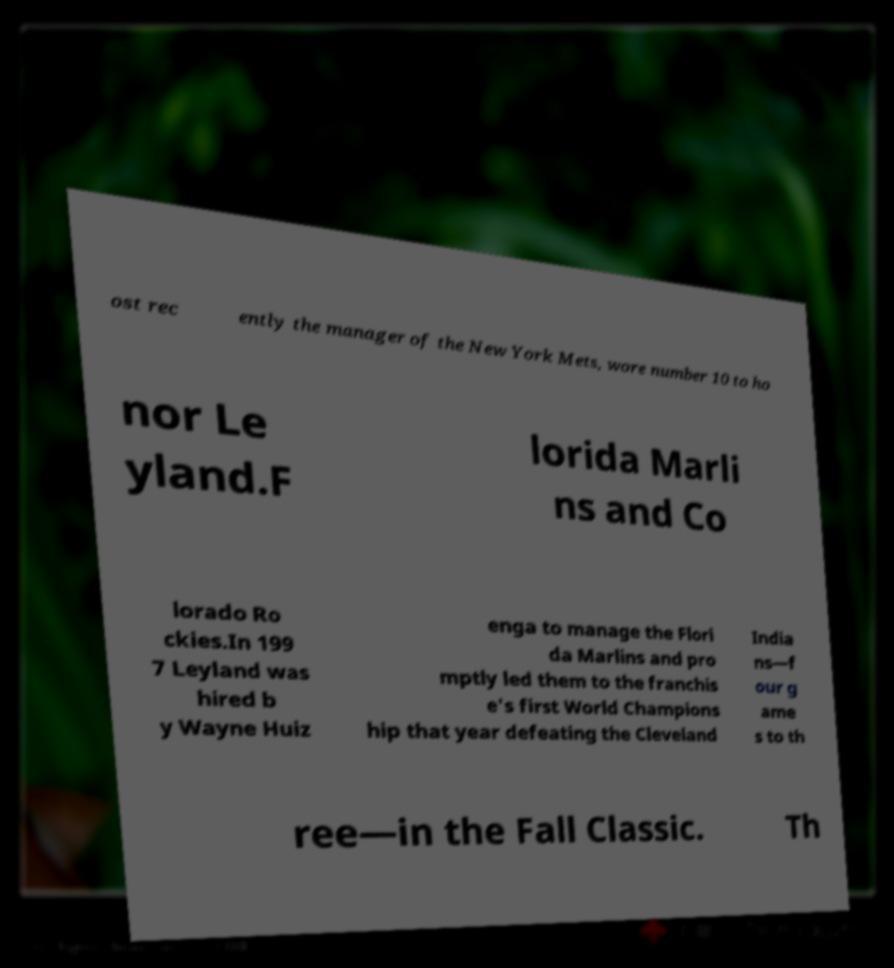Can you accurately transcribe the text from the provided image for me? ost rec ently the manager of the New York Mets, wore number 10 to ho nor Le yland.F lorida Marli ns and Co lorado Ro ckies.In 199 7 Leyland was hired b y Wayne Huiz enga to manage the Flori da Marlins and pro mptly led them to the franchis e's first World Champions hip that year defeating the Cleveland India ns—f our g ame s to th ree—in the Fall Classic. Th 